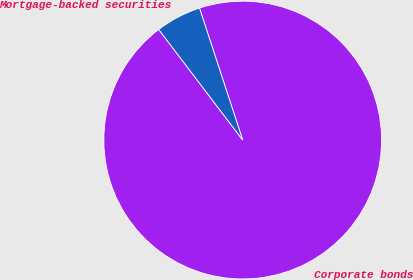<chart> <loc_0><loc_0><loc_500><loc_500><pie_chart><fcel>Corporate bonds<fcel>Mortgage-backed securities<nl><fcel>94.7%<fcel>5.3%<nl></chart> 